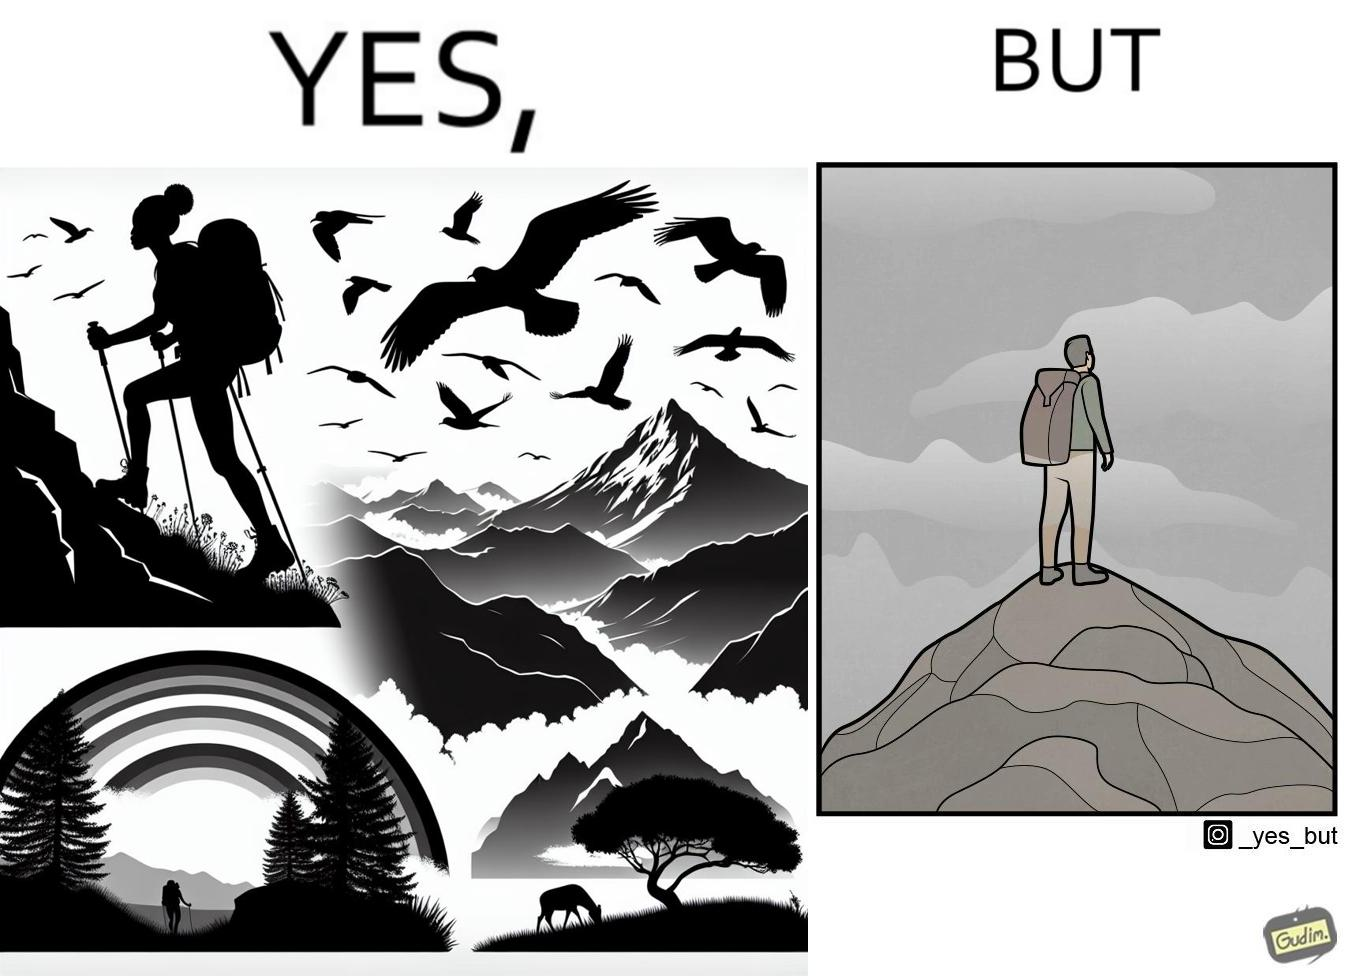What is the satirical meaning behind this image? The image is ironic, because the mountaineer climbs up the mountain to view the world from the peak but due to so much cloud, at the top, nothing is visible whereas he was able to witness some awesome views while climbing up the mountain 